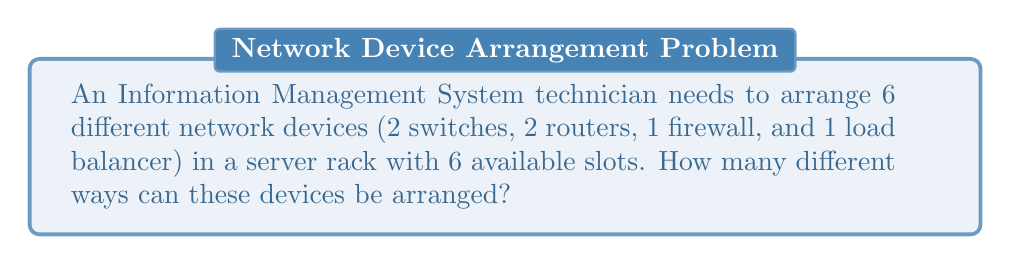Teach me how to tackle this problem. Let's approach this step-by-step:

1) This is a permutation problem, as the order of the devices matters in the server rack.

2) We have 6 distinct positions and 6 distinct devices to arrange.

3) The formula for permutations of n distinct objects is:

   $$P(n) = n!$$

4) In this case, n = 6, so we have:

   $$P(6) = 6!$$

5) Let's calculate 6!:
   
   $$6! = 6 \times 5 \times 4 \times 3 \times 2 \times 1 = 720$$

6) Therefore, there are 720 different ways to arrange these 6 network devices in the server rack.

Note: The fact that there are 2 switches and 2 routers doesn't affect the calculation because we're assuming each device is distinct (e.g., Switch 1 and Switch 2 are considered different devices).
Answer: 720 